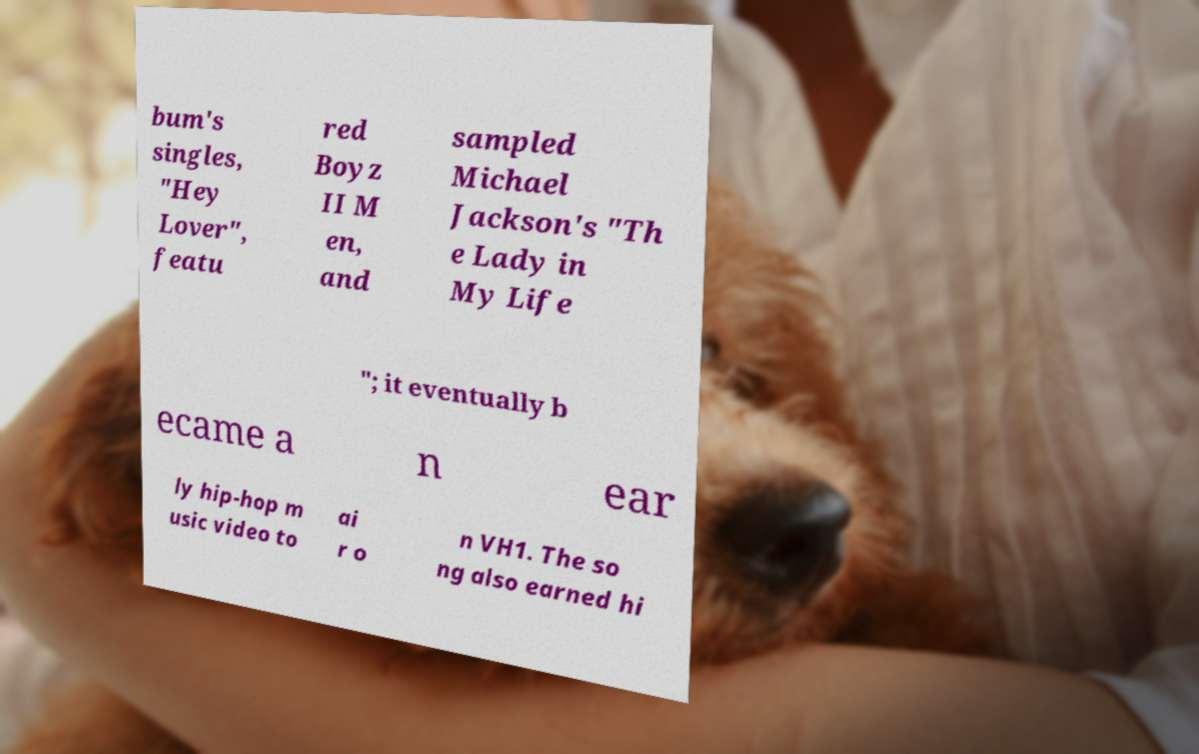Can you accurately transcribe the text from the provided image for me? bum's singles, "Hey Lover", featu red Boyz II M en, and sampled Michael Jackson's "Th e Lady in My Life "; it eventually b ecame a n ear ly hip-hop m usic video to ai r o n VH1. The so ng also earned hi 